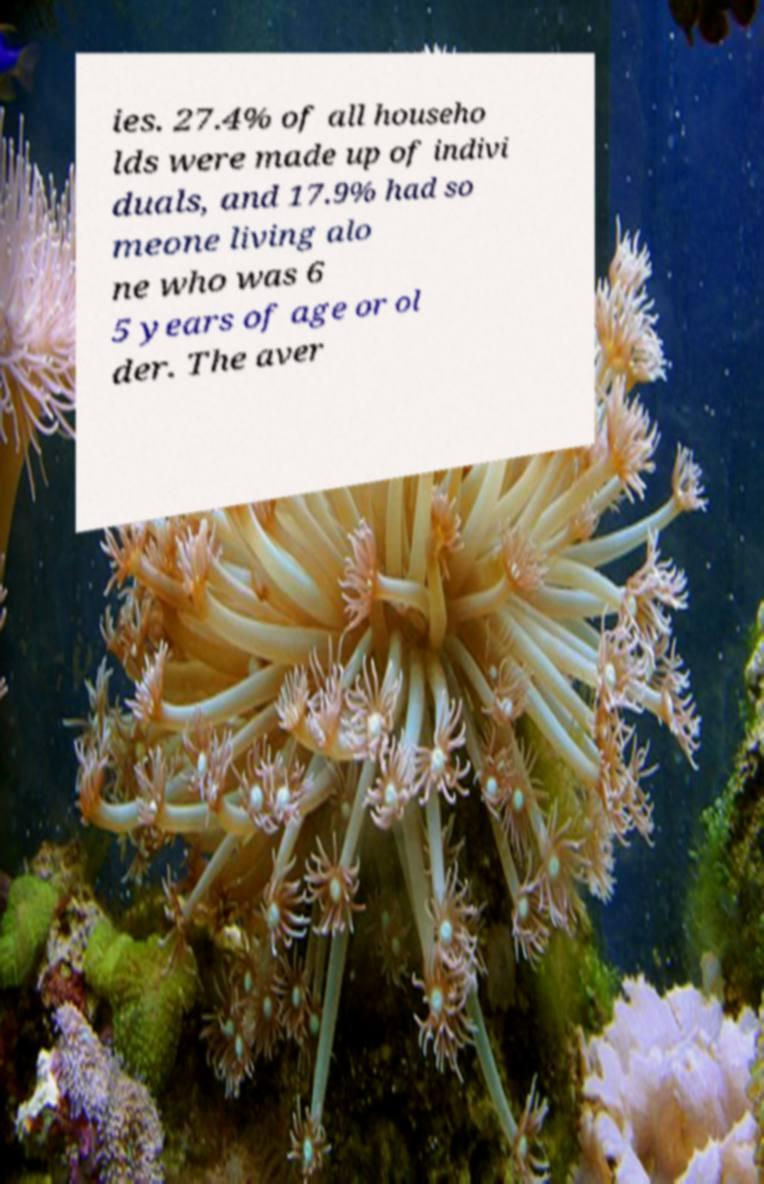Please read and relay the text visible in this image. What does it say? ies. 27.4% of all househo lds were made up of indivi duals, and 17.9% had so meone living alo ne who was 6 5 years of age or ol der. The aver 